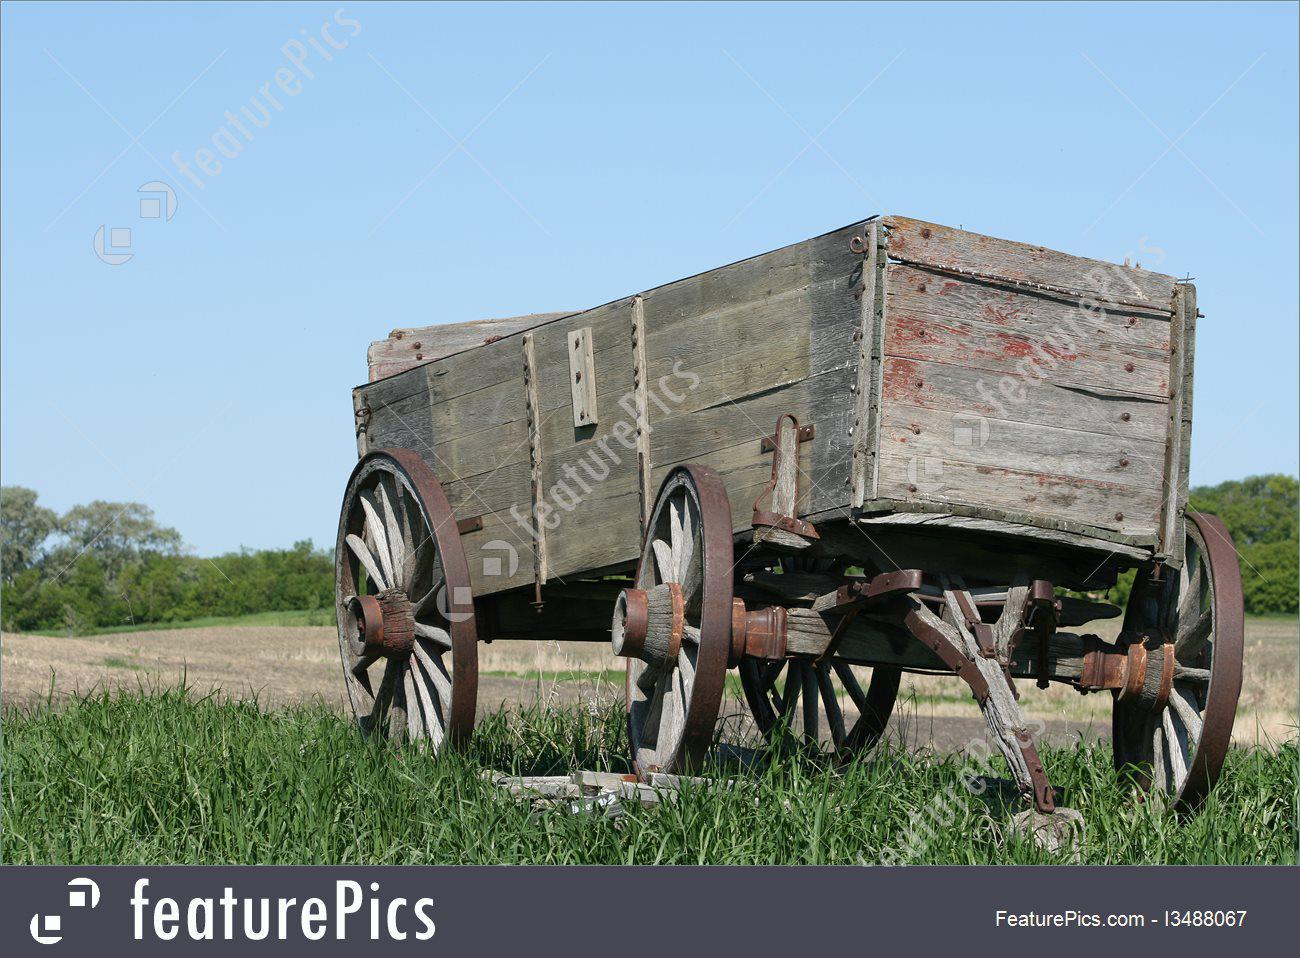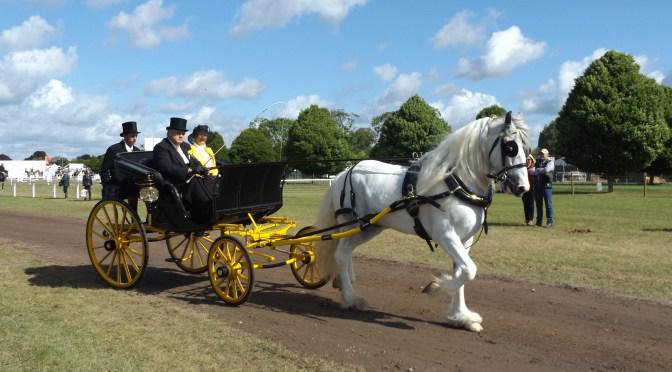The first image is the image on the left, the second image is the image on the right. Examine the images to the left and right. Is the description "Five or fewer mammals are visible." accurate? Answer yes or no. No. The first image is the image on the left, the second image is the image on the right. Examine the images to the left and right. Is the description "The left image shows a carriage but no horses." accurate? Answer yes or no. Yes. 